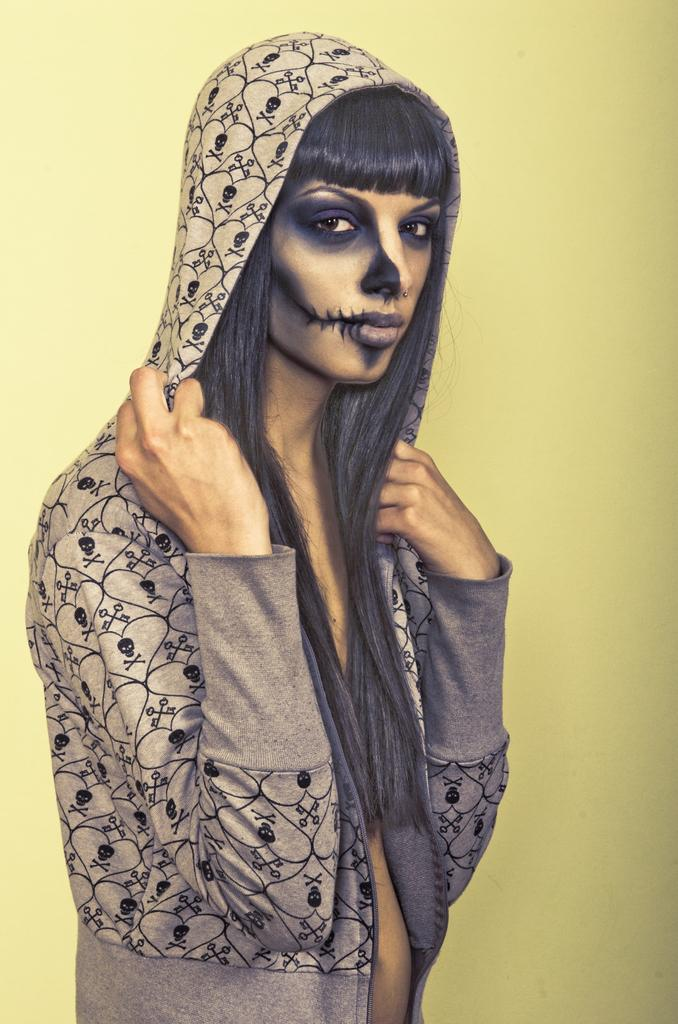Who is the main subject in the image? There is a woman in the image. What is the woman wearing? The woman is wearing a jacket. What is the woman doing in the image? The woman is standing. What can be seen in the background of the image? There is a wall in the background of the image. What is the color of the wall? The wall is yellow in color. What is the woman's gaze directed towards in the image? The woman is looking at the camera. Can you tell me how many oranges are on the woman's head in the image? There are no oranges present in the image; the woman is wearing a jacket and standing in front of a yellow wall. 